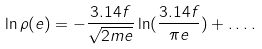<formula> <loc_0><loc_0><loc_500><loc_500>\ln \rho ( e ) = - \frac { 3 . 1 4 f } { \sqrt { 2 m e } } \ln ( \frac { 3 . 1 4 f } { \pi e } ) + \dots .</formula> 